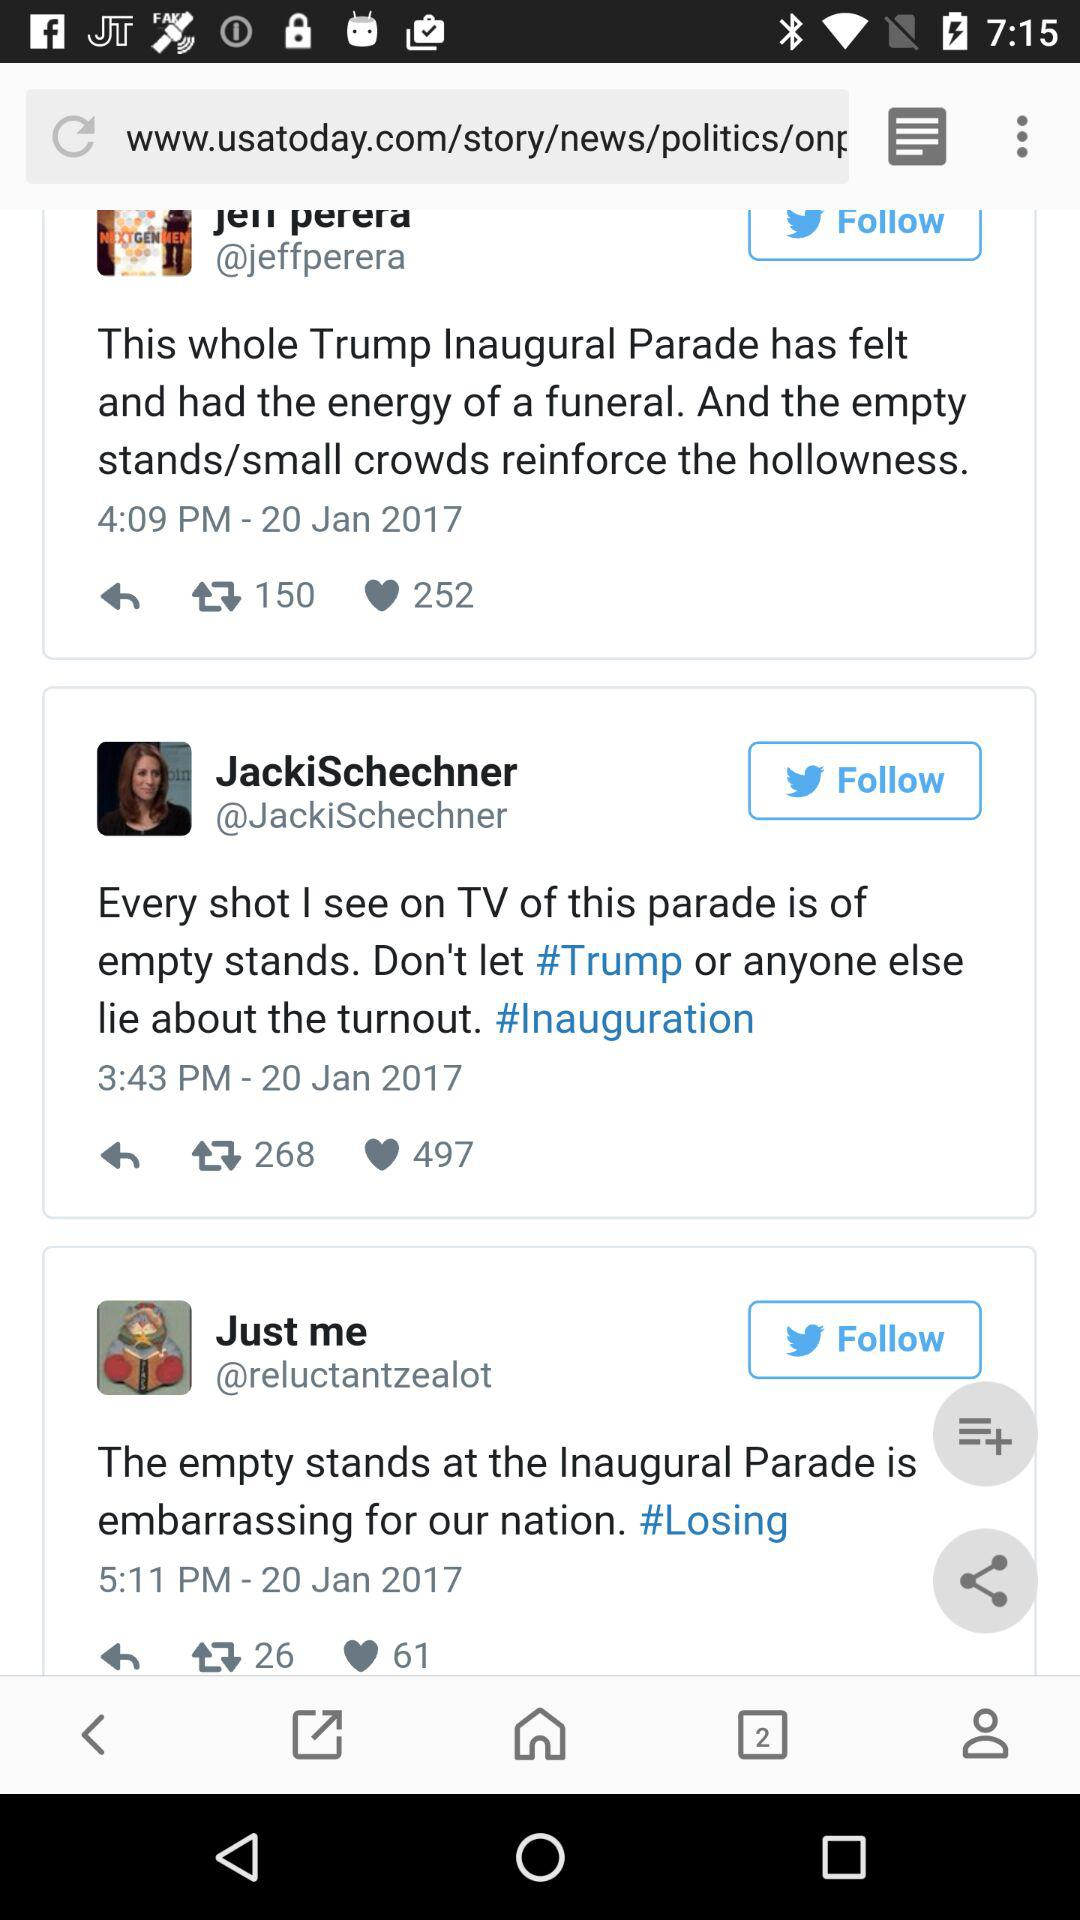How many likes are there of the post posted by "Just me"? There are 61 likes of the post by "Just me". 